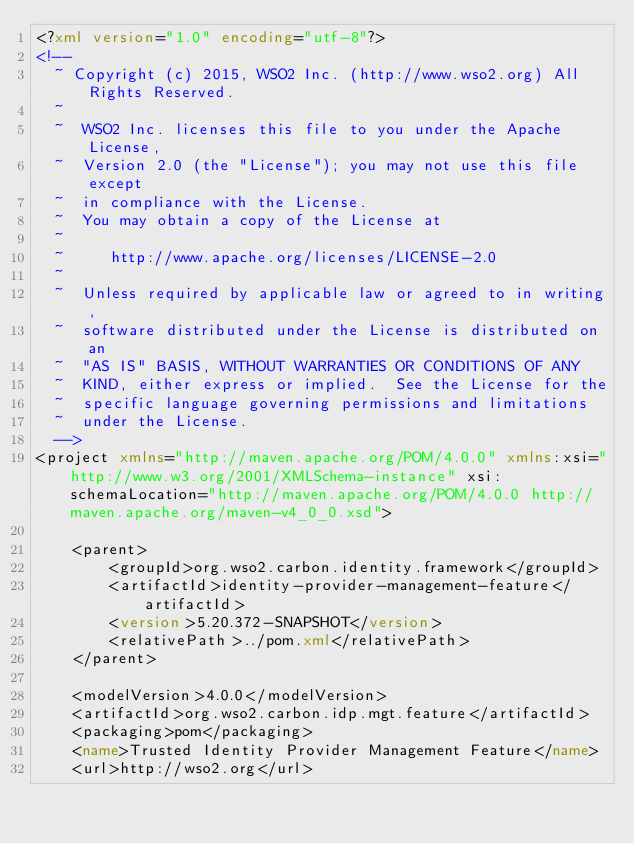Convert code to text. <code><loc_0><loc_0><loc_500><loc_500><_XML_><?xml version="1.0" encoding="utf-8"?>
<!--
  ~ Copyright (c) 2015, WSO2 Inc. (http://www.wso2.org) All Rights Reserved.
  ~
  ~  WSO2 Inc. licenses this file to you under the Apache License,
  ~  Version 2.0 (the "License"); you may not use this file except
  ~  in compliance with the License.
  ~  You may obtain a copy of the License at
  ~
  ~     http://www.apache.org/licenses/LICENSE-2.0
  ~
  ~  Unless required by applicable law or agreed to in writing,
  ~  software distributed under the License is distributed on an
  ~  "AS IS" BASIS, WITHOUT WARRANTIES OR CONDITIONS OF ANY
  ~  KIND, either express or implied.  See the License for the
  ~  specific language governing permissions and limitations
  ~  under the License.
  -->
<project xmlns="http://maven.apache.org/POM/4.0.0" xmlns:xsi="http://www.w3.org/2001/XMLSchema-instance" xsi:schemaLocation="http://maven.apache.org/POM/4.0.0 http://maven.apache.org/maven-v4_0_0.xsd">

    <parent>
        <groupId>org.wso2.carbon.identity.framework</groupId>
        <artifactId>identity-provider-management-feature</artifactId>
        <version>5.20.372-SNAPSHOT</version>
        <relativePath>../pom.xml</relativePath>
    </parent>

    <modelVersion>4.0.0</modelVersion>
    <artifactId>org.wso2.carbon.idp.mgt.feature</artifactId>
    <packaging>pom</packaging>
    <name>Trusted Identity Provider Management Feature</name>
    <url>http://wso2.org</url></code> 